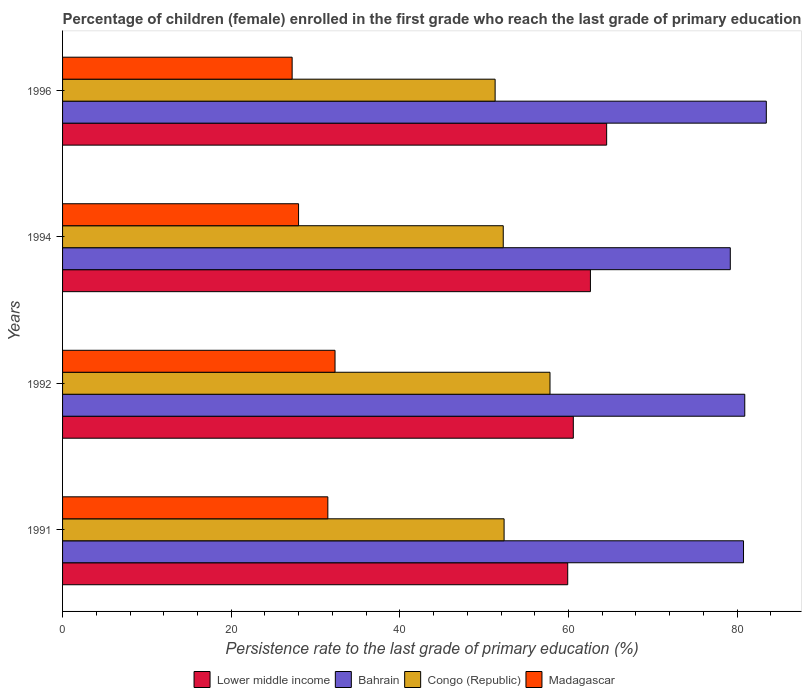Are the number of bars on each tick of the Y-axis equal?
Your answer should be very brief. Yes. How many bars are there on the 3rd tick from the top?
Ensure brevity in your answer.  4. What is the persistence rate of children in Lower middle income in 1994?
Give a very brief answer. 62.61. Across all years, what is the maximum persistence rate of children in Lower middle income?
Ensure brevity in your answer.  64.53. Across all years, what is the minimum persistence rate of children in Bahrain?
Ensure brevity in your answer.  79.19. In which year was the persistence rate of children in Madagascar maximum?
Provide a succinct answer. 1992. What is the total persistence rate of children in Madagascar in the graph?
Offer a very short reply. 119. What is the difference between the persistence rate of children in Congo (Republic) in 1991 and that in 1994?
Provide a succinct answer. 0.1. What is the difference between the persistence rate of children in Lower middle income in 1992 and the persistence rate of children in Congo (Republic) in 1996?
Provide a succinct answer. 9.27. What is the average persistence rate of children in Congo (Republic) per year?
Offer a very short reply. 53.44. In the year 1992, what is the difference between the persistence rate of children in Lower middle income and persistence rate of children in Bahrain?
Your answer should be very brief. -20.33. What is the ratio of the persistence rate of children in Lower middle income in 1991 to that in 1996?
Offer a very short reply. 0.93. Is the difference between the persistence rate of children in Lower middle income in 1992 and 1996 greater than the difference between the persistence rate of children in Bahrain in 1992 and 1996?
Provide a succinct answer. No. What is the difference between the highest and the second highest persistence rate of children in Lower middle income?
Ensure brevity in your answer.  1.93. What is the difference between the highest and the lowest persistence rate of children in Madagascar?
Keep it short and to the point. 5.09. In how many years, is the persistence rate of children in Bahrain greater than the average persistence rate of children in Bahrain taken over all years?
Provide a succinct answer. 1. Is the sum of the persistence rate of children in Bahrain in 1991 and 1994 greater than the maximum persistence rate of children in Congo (Republic) across all years?
Make the answer very short. Yes. Is it the case that in every year, the sum of the persistence rate of children in Lower middle income and persistence rate of children in Madagascar is greater than the sum of persistence rate of children in Bahrain and persistence rate of children in Congo (Republic)?
Your response must be concise. No. What does the 4th bar from the top in 1991 represents?
Provide a short and direct response. Lower middle income. What does the 3rd bar from the bottom in 1994 represents?
Make the answer very short. Congo (Republic). Is it the case that in every year, the sum of the persistence rate of children in Madagascar and persistence rate of children in Lower middle income is greater than the persistence rate of children in Congo (Republic)?
Offer a very short reply. Yes. How many years are there in the graph?
Keep it short and to the point. 4. Are the values on the major ticks of X-axis written in scientific E-notation?
Your response must be concise. No. How many legend labels are there?
Your answer should be compact. 4. What is the title of the graph?
Your answer should be very brief. Percentage of children (female) enrolled in the first grade who reach the last grade of primary education. Does "Antigua and Barbuda" appear as one of the legend labels in the graph?
Make the answer very short. No. What is the label or title of the X-axis?
Your answer should be compact. Persistence rate to the last grade of primary education (%). What is the Persistence rate to the last grade of primary education (%) of Lower middle income in 1991?
Offer a terse response. 59.91. What is the Persistence rate to the last grade of primary education (%) of Bahrain in 1991?
Give a very brief answer. 80.76. What is the Persistence rate to the last grade of primary education (%) in Congo (Republic) in 1991?
Offer a terse response. 52.37. What is the Persistence rate to the last grade of primary education (%) in Madagascar in 1991?
Provide a succinct answer. 31.46. What is the Persistence rate to the last grade of primary education (%) of Lower middle income in 1992?
Make the answer very short. 60.58. What is the Persistence rate to the last grade of primary education (%) in Bahrain in 1992?
Offer a terse response. 80.91. What is the Persistence rate to the last grade of primary education (%) in Congo (Republic) in 1992?
Your answer should be very brief. 57.81. What is the Persistence rate to the last grade of primary education (%) in Madagascar in 1992?
Provide a short and direct response. 32.32. What is the Persistence rate to the last grade of primary education (%) of Lower middle income in 1994?
Offer a very short reply. 62.61. What is the Persistence rate to the last grade of primary education (%) in Bahrain in 1994?
Ensure brevity in your answer.  79.19. What is the Persistence rate to the last grade of primary education (%) in Congo (Republic) in 1994?
Provide a short and direct response. 52.27. What is the Persistence rate to the last grade of primary education (%) in Madagascar in 1994?
Your answer should be very brief. 27.99. What is the Persistence rate to the last grade of primary education (%) in Lower middle income in 1996?
Your response must be concise. 64.53. What is the Persistence rate to the last grade of primary education (%) of Bahrain in 1996?
Offer a very short reply. 83.47. What is the Persistence rate to the last grade of primary education (%) of Congo (Republic) in 1996?
Provide a short and direct response. 51.3. What is the Persistence rate to the last grade of primary education (%) in Madagascar in 1996?
Offer a very short reply. 27.23. Across all years, what is the maximum Persistence rate to the last grade of primary education (%) of Lower middle income?
Your response must be concise. 64.53. Across all years, what is the maximum Persistence rate to the last grade of primary education (%) of Bahrain?
Offer a very short reply. 83.47. Across all years, what is the maximum Persistence rate to the last grade of primary education (%) of Congo (Republic)?
Your answer should be compact. 57.81. Across all years, what is the maximum Persistence rate to the last grade of primary education (%) of Madagascar?
Your response must be concise. 32.32. Across all years, what is the minimum Persistence rate to the last grade of primary education (%) in Lower middle income?
Provide a succinct answer. 59.91. Across all years, what is the minimum Persistence rate to the last grade of primary education (%) of Bahrain?
Offer a terse response. 79.19. Across all years, what is the minimum Persistence rate to the last grade of primary education (%) of Congo (Republic)?
Ensure brevity in your answer.  51.3. Across all years, what is the minimum Persistence rate to the last grade of primary education (%) of Madagascar?
Give a very brief answer. 27.23. What is the total Persistence rate to the last grade of primary education (%) in Lower middle income in the graph?
Provide a succinct answer. 247.63. What is the total Persistence rate to the last grade of primary education (%) in Bahrain in the graph?
Provide a succinct answer. 324.34. What is the total Persistence rate to the last grade of primary education (%) in Congo (Republic) in the graph?
Keep it short and to the point. 213.75. What is the total Persistence rate to the last grade of primary education (%) of Madagascar in the graph?
Provide a short and direct response. 119. What is the difference between the Persistence rate to the last grade of primary education (%) in Lower middle income in 1991 and that in 1992?
Offer a very short reply. -0.66. What is the difference between the Persistence rate to the last grade of primary education (%) of Bahrain in 1991 and that in 1992?
Your response must be concise. -0.15. What is the difference between the Persistence rate to the last grade of primary education (%) in Congo (Republic) in 1991 and that in 1992?
Make the answer very short. -5.44. What is the difference between the Persistence rate to the last grade of primary education (%) of Madagascar in 1991 and that in 1992?
Offer a terse response. -0.85. What is the difference between the Persistence rate to the last grade of primary education (%) of Lower middle income in 1991 and that in 1994?
Keep it short and to the point. -2.69. What is the difference between the Persistence rate to the last grade of primary education (%) of Bahrain in 1991 and that in 1994?
Give a very brief answer. 1.57. What is the difference between the Persistence rate to the last grade of primary education (%) of Congo (Republic) in 1991 and that in 1994?
Keep it short and to the point. 0.1. What is the difference between the Persistence rate to the last grade of primary education (%) of Madagascar in 1991 and that in 1994?
Make the answer very short. 3.47. What is the difference between the Persistence rate to the last grade of primary education (%) in Lower middle income in 1991 and that in 1996?
Your answer should be very brief. -4.62. What is the difference between the Persistence rate to the last grade of primary education (%) in Bahrain in 1991 and that in 1996?
Provide a succinct answer. -2.7. What is the difference between the Persistence rate to the last grade of primary education (%) of Congo (Republic) in 1991 and that in 1996?
Your response must be concise. 1.06. What is the difference between the Persistence rate to the last grade of primary education (%) of Madagascar in 1991 and that in 1996?
Offer a very short reply. 4.23. What is the difference between the Persistence rate to the last grade of primary education (%) of Lower middle income in 1992 and that in 1994?
Make the answer very short. -2.03. What is the difference between the Persistence rate to the last grade of primary education (%) in Bahrain in 1992 and that in 1994?
Make the answer very short. 1.72. What is the difference between the Persistence rate to the last grade of primary education (%) of Congo (Republic) in 1992 and that in 1994?
Offer a terse response. 5.54. What is the difference between the Persistence rate to the last grade of primary education (%) of Madagascar in 1992 and that in 1994?
Keep it short and to the point. 4.33. What is the difference between the Persistence rate to the last grade of primary education (%) of Lower middle income in 1992 and that in 1996?
Offer a terse response. -3.96. What is the difference between the Persistence rate to the last grade of primary education (%) in Bahrain in 1992 and that in 1996?
Give a very brief answer. -2.55. What is the difference between the Persistence rate to the last grade of primary education (%) of Congo (Republic) in 1992 and that in 1996?
Offer a terse response. 6.51. What is the difference between the Persistence rate to the last grade of primary education (%) in Madagascar in 1992 and that in 1996?
Provide a short and direct response. 5.09. What is the difference between the Persistence rate to the last grade of primary education (%) of Lower middle income in 1994 and that in 1996?
Offer a very short reply. -1.93. What is the difference between the Persistence rate to the last grade of primary education (%) in Bahrain in 1994 and that in 1996?
Provide a succinct answer. -4.27. What is the difference between the Persistence rate to the last grade of primary education (%) in Madagascar in 1994 and that in 1996?
Keep it short and to the point. 0.76. What is the difference between the Persistence rate to the last grade of primary education (%) in Lower middle income in 1991 and the Persistence rate to the last grade of primary education (%) in Bahrain in 1992?
Keep it short and to the point. -21. What is the difference between the Persistence rate to the last grade of primary education (%) of Lower middle income in 1991 and the Persistence rate to the last grade of primary education (%) of Congo (Republic) in 1992?
Provide a succinct answer. 2.1. What is the difference between the Persistence rate to the last grade of primary education (%) of Lower middle income in 1991 and the Persistence rate to the last grade of primary education (%) of Madagascar in 1992?
Offer a terse response. 27.6. What is the difference between the Persistence rate to the last grade of primary education (%) of Bahrain in 1991 and the Persistence rate to the last grade of primary education (%) of Congo (Republic) in 1992?
Keep it short and to the point. 22.95. What is the difference between the Persistence rate to the last grade of primary education (%) in Bahrain in 1991 and the Persistence rate to the last grade of primary education (%) in Madagascar in 1992?
Make the answer very short. 48.45. What is the difference between the Persistence rate to the last grade of primary education (%) of Congo (Republic) in 1991 and the Persistence rate to the last grade of primary education (%) of Madagascar in 1992?
Ensure brevity in your answer.  20.05. What is the difference between the Persistence rate to the last grade of primary education (%) in Lower middle income in 1991 and the Persistence rate to the last grade of primary education (%) in Bahrain in 1994?
Offer a terse response. -19.28. What is the difference between the Persistence rate to the last grade of primary education (%) of Lower middle income in 1991 and the Persistence rate to the last grade of primary education (%) of Congo (Republic) in 1994?
Give a very brief answer. 7.64. What is the difference between the Persistence rate to the last grade of primary education (%) in Lower middle income in 1991 and the Persistence rate to the last grade of primary education (%) in Madagascar in 1994?
Provide a succinct answer. 31.92. What is the difference between the Persistence rate to the last grade of primary education (%) of Bahrain in 1991 and the Persistence rate to the last grade of primary education (%) of Congo (Republic) in 1994?
Your answer should be compact. 28.5. What is the difference between the Persistence rate to the last grade of primary education (%) in Bahrain in 1991 and the Persistence rate to the last grade of primary education (%) in Madagascar in 1994?
Provide a short and direct response. 52.77. What is the difference between the Persistence rate to the last grade of primary education (%) in Congo (Republic) in 1991 and the Persistence rate to the last grade of primary education (%) in Madagascar in 1994?
Provide a succinct answer. 24.38. What is the difference between the Persistence rate to the last grade of primary education (%) of Lower middle income in 1991 and the Persistence rate to the last grade of primary education (%) of Bahrain in 1996?
Your answer should be compact. -23.55. What is the difference between the Persistence rate to the last grade of primary education (%) of Lower middle income in 1991 and the Persistence rate to the last grade of primary education (%) of Congo (Republic) in 1996?
Your answer should be compact. 8.61. What is the difference between the Persistence rate to the last grade of primary education (%) of Lower middle income in 1991 and the Persistence rate to the last grade of primary education (%) of Madagascar in 1996?
Provide a short and direct response. 32.68. What is the difference between the Persistence rate to the last grade of primary education (%) in Bahrain in 1991 and the Persistence rate to the last grade of primary education (%) in Congo (Republic) in 1996?
Offer a terse response. 29.46. What is the difference between the Persistence rate to the last grade of primary education (%) in Bahrain in 1991 and the Persistence rate to the last grade of primary education (%) in Madagascar in 1996?
Make the answer very short. 53.54. What is the difference between the Persistence rate to the last grade of primary education (%) in Congo (Republic) in 1991 and the Persistence rate to the last grade of primary education (%) in Madagascar in 1996?
Make the answer very short. 25.14. What is the difference between the Persistence rate to the last grade of primary education (%) in Lower middle income in 1992 and the Persistence rate to the last grade of primary education (%) in Bahrain in 1994?
Offer a very short reply. -18.62. What is the difference between the Persistence rate to the last grade of primary education (%) of Lower middle income in 1992 and the Persistence rate to the last grade of primary education (%) of Congo (Republic) in 1994?
Provide a short and direct response. 8.31. What is the difference between the Persistence rate to the last grade of primary education (%) in Lower middle income in 1992 and the Persistence rate to the last grade of primary education (%) in Madagascar in 1994?
Your answer should be compact. 32.59. What is the difference between the Persistence rate to the last grade of primary education (%) in Bahrain in 1992 and the Persistence rate to the last grade of primary education (%) in Congo (Republic) in 1994?
Provide a short and direct response. 28.64. What is the difference between the Persistence rate to the last grade of primary education (%) in Bahrain in 1992 and the Persistence rate to the last grade of primary education (%) in Madagascar in 1994?
Ensure brevity in your answer.  52.92. What is the difference between the Persistence rate to the last grade of primary education (%) in Congo (Republic) in 1992 and the Persistence rate to the last grade of primary education (%) in Madagascar in 1994?
Keep it short and to the point. 29.82. What is the difference between the Persistence rate to the last grade of primary education (%) of Lower middle income in 1992 and the Persistence rate to the last grade of primary education (%) of Bahrain in 1996?
Your answer should be very brief. -22.89. What is the difference between the Persistence rate to the last grade of primary education (%) in Lower middle income in 1992 and the Persistence rate to the last grade of primary education (%) in Congo (Republic) in 1996?
Offer a terse response. 9.27. What is the difference between the Persistence rate to the last grade of primary education (%) in Lower middle income in 1992 and the Persistence rate to the last grade of primary education (%) in Madagascar in 1996?
Ensure brevity in your answer.  33.35. What is the difference between the Persistence rate to the last grade of primary education (%) of Bahrain in 1992 and the Persistence rate to the last grade of primary education (%) of Congo (Republic) in 1996?
Make the answer very short. 29.61. What is the difference between the Persistence rate to the last grade of primary education (%) of Bahrain in 1992 and the Persistence rate to the last grade of primary education (%) of Madagascar in 1996?
Your response must be concise. 53.68. What is the difference between the Persistence rate to the last grade of primary education (%) of Congo (Republic) in 1992 and the Persistence rate to the last grade of primary education (%) of Madagascar in 1996?
Keep it short and to the point. 30.58. What is the difference between the Persistence rate to the last grade of primary education (%) in Lower middle income in 1994 and the Persistence rate to the last grade of primary education (%) in Bahrain in 1996?
Your answer should be very brief. -20.86. What is the difference between the Persistence rate to the last grade of primary education (%) of Lower middle income in 1994 and the Persistence rate to the last grade of primary education (%) of Congo (Republic) in 1996?
Give a very brief answer. 11.3. What is the difference between the Persistence rate to the last grade of primary education (%) in Lower middle income in 1994 and the Persistence rate to the last grade of primary education (%) in Madagascar in 1996?
Keep it short and to the point. 35.38. What is the difference between the Persistence rate to the last grade of primary education (%) in Bahrain in 1994 and the Persistence rate to the last grade of primary education (%) in Congo (Republic) in 1996?
Make the answer very short. 27.89. What is the difference between the Persistence rate to the last grade of primary education (%) in Bahrain in 1994 and the Persistence rate to the last grade of primary education (%) in Madagascar in 1996?
Your answer should be very brief. 51.97. What is the difference between the Persistence rate to the last grade of primary education (%) in Congo (Republic) in 1994 and the Persistence rate to the last grade of primary education (%) in Madagascar in 1996?
Offer a terse response. 25.04. What is the average Persistence rate to the last grade of primary education (%) in Lower middle income per year?
Provide a short and direct response. 61.91. What is the average Persistence rate to the last grade of primary education (%) in Bahrain per year?
Your answer should be very brief. 81.08. What is the average Persistence rate to the last grade of primary education (%) in Congo (Republic) per year?
Your answer should be compact. 53.44. What is the average Persistence rate to the last grade of primary education (%) in Madagascar per year?
Offer a very short reply. 29.75. In the year 1991, what is the difference between the Persistence rate to the last grade of primary education (%) of Lower middle income and Persistence rate to the last grade of primary education (%) of Bahrain?
Offer a terse response. -20.85. In the year 1991, what is the difference between the Persistence rate to the last grade of primary education (%) in Lower middle income and Persistence rate to the last grade of primary education (%) in Congo (Republic)?
Give a very brief answer. 7.55. In the year 1991, what is the difference between the Persistence rate to the last grade of primary education (%) of Lower middle income and Persistence rate to the last grade of primary education (%) of Madagascar?
Your response must be concise. 28.45. In the year 1991, what is the difference between the Persistence rate to the last grade of primary education (%) of Bahrain and Persistence rate to the last grade of primary education (%) of Congo (Republic)?
Keep it short and to the point. 28.4. In the year 1991, what is the difference between the Persistence rate to the last grade of primary education (%) in Bahrain and Persistence rate to the last grade of primary education (%) in Madagascar?
Offer a terse response. 49.3. In the year 1991, what is the difference between the Persistence rate to the last grade of primary education (%) of Congo (Republic) and Persistence rate to the last grade of primary education (%) of Madagascar?
Keep it short and to the point. 20.9. In the year 1992, what is the difference between the Persistence rate to the last grade of primary education (%) in Lower middle income and Persistence rate to the last grade of primary education (%) in Bahrain?
Your answer should be very brief. -20.33. In the year 1992, what is the difference between the Persistence rate to the last grade of primary education (%) in Lower middle income and Persistence rate to the last grade of primary education (%) in Congo (Republic)?
Your response must be concise. 2.77. In the year 1992, what is the difference between the Persistence rate to the last grade of primary education (%) of Lower middle income and Persistence rate to the last grade of primary education (%) of Madagascar?
Your answer should be very brief. 28.26. In the year 1992, what is the difference between the Persistence rate to the last grade of primary education (%) of Bahrain and Persistence rate to the last grade of primary education (%) of Congo (Republic)?
Make the answer very short. 23.1. In the year 1992, what is the difference between the Persistence rate to the last grade of primary education (%) in Bahrain and Persistence rate to the last grade of primary education (%) in Madagascar?
Give a very brief answer. 48.6. In the year 1992, what is the difference between the Persistence rate to the last grade of primary education (%) of Congo (Republic) and Persistence rate to the last grade of primary education (%) of Madagascar?
Give a very brief answer. 25.5. In the year 1994, what is the difference between the Persistence rate to the last grade of primary education (%) in Lower middle income and Persistence rate to the last grade of primary education (%) in Bahrain?
Your answer should be very brief. -16.59. In the year 1994, what is the difference between the Persistence rate to the last grade of primary education (%) of Lower middle income and Persistence rate to the last grade of primary education (%) of Congo (Republic)?
Make the answer very short. 10.34. In the year 1994, what is the difference between the Persistence rate to the last grade of primary education (%) of Lower middle income and Persistence rate to the last grade of primary education (%) of Madagascar?
Make the answer very short. 34.62. In the year 1994, what is the difference between the Persistence rate to the last grade of primary education (%) in Bahrain and Persistence rate to the last grade of primary education (%) in Congo (Republic)?
Provide a short and direct response. 26.93. In the year 1994, what is the difference between the Persistence rate to the last grade of primary education (%) in Bahrain and Persistence rate to the last grade of primary education (%) in Madagascar?
Offer a terse response. 51.2. In the year 1994, what is the difference between the Persistence rate to the last grade of primary education (%) in Congo (Republic) and Persistence rate to the last grade of primary education (%) in Madagascar?
Your answer should be very brief. 24.28. In the year 1996, what is the difference between the Persistence rate to the last grade of primary education (%) in Lower middle income and Persistence rate to the last grade of primary education (%) in Bahrain?
Make the answer very short. -18.93. In the year 1996, what is the difference between the Persistence rate to the last grade of primary education (%) of Lower middle income and Persistence rate to the last grade of primary education (%) of Congo (Republic)?
Ensure brevity in your answer.  13.23. In the year 1996, what is the difference between the Persistence rate to the last grade of primary education (%) in Lower middle income and Persistence rate to the last grade of primary education (%) in Madagascar?
Your answer should be compact. 37.3. In the year 1996, what is the difference between the Persistence rate to the last grade of primary education (%) of Bahrain and Persistence rate to the last grade of primary education (%) of Congo (Republic)?
Ensure brevity in your answer.  32.16. In the year 1996, what is the difference between the Persistence rate to the last grade of primary education (%) in Bahrain and Persistence rate to the last grade of primary education (%) in Madagascar?
Provide a succinct answer. 56.24. In the year 1996, what is the difference between the Persistence rate to the last grade of primary education (%) of Congo (Republic) and Persistence rate to the last grade of primary education (%) of Madagascar?
Offer a terse response. 24.07. What is the ratio of the Persistence rate to the last grade of primary education (%) of Bahrain in 1991 to that in 1992?
Offer a terse response. 1. What is the ratio of the Persistence rate to the last grade of primary education (%) in Congo (Republic) in 1991 to that in 1992?
Offer a terse response. 0.91. What is the ratio of the Persistence rate to the last grade of primary education (%) of Madagascar in 1991 to that in 1992?
Keep it short and to the point. 0.97. What is the ratio of the Persistence rate to the last grade of primary education (%) in Bahrain in 1991 to that in 1994?
Keep it short and to the point. 1.02. What is the ratio of the Persistence rate to the last grade of primary education (%) of Congo (Republic) in 1991 to that in 1994?
Ensure brevity in your answer.  1. What is the ratio of the Persistence rate to the last grade of primary education (%) of Madagascar in 1991 to that in 1994?
Your answer should be very brief. 1.12. What is the ratio of the Persistence rate to the last grade of primary education (%) in Lower middle income in 1991 to that in 1996?
Your response must be concise. 0.93. What is the ratio of the Persistence rate to the last grade of primary education (%) in Bahrain in 1991 to that in 1996?
Make the answer very short. 0.97. What is the ratio of the Persistence rate to the last grade of primary education (%) of Congo (Republic) in 1991 to that in 1996?
Offer a terse response. 1.02. What is the ratio of the Persistence rate to the last grade of primary education (%) in Madagascar in 1991 to that in 1996?
Give a very brief answer. 1.16. What is the ratio of the Persistence rate to the last grade of primary education (%) in Lower middle income in 1992 to that in 1994?
Your answer should be very brief. 0.97. What is the ratio of the Persistence rate to the last grade of primary education (%) in Bahrain in 1992 to that in 1994?
Provide a short and direct response. 1.02. What is the ratio of the Persistence rate to the last grade of primary education (%) in Congo (Republic) in 1992 to that in 1994?
Offer a terse response. 1.11. What is the ratio of the Persistence rate to the last grade of primary education (%) of Madagascar in 1992 to that in 1994?
Your answer should be compact. 1.15. What is the ratio of the Persistence rate to the last grade of primary education (%) in Lower middle income in 1992 to that in 1996?
Your answer should be very brief. 0.94. What is the ratio of the Persistence rate to the last grade of primary education (%) in Bahrain in 1992 to that in 1996?
Keep it short and to the point. 0.97. What is the ratio of the Persistence rate to the last grade of primary education (%) in Congo (Republic) in 1992 to that in 1996?
Your answer should be compact. 1.13. What is the ratio of the Persistence rate to the last grade of primary education (%) in Madagascar in 1992 to that in 1996?
Your response must be concise. 1.19. What is the ratio of the Persistence rate to the last grade of primary education (%) of Lower middle income in 1994 to that in 1996?
Your answer should be compact. 0.97. What is the ratio of the Persistence rate to the last grade of primary education (%) in Bahrain in 1994 to that in 1996?
Your response must be concise. 0.95. What is the ratio of the Persistence rate to the last grade of primary education (%) of Congo (Republic) in 1994 to that in 1996?
Ensure brevity in your answer.  1.02. What is the ratio of the Persistence rate to the last grade of primary education (%) in Madagascar in 1994 to that in 1996?
Keep it short and to the point. 1.03. What is the difference between the highest and the second highest Persistence rate to the last grade of primary education (%) in Lower middle income?
Your answer should be very brief. 1.93. What is the difference between the highest and the second highest Persistence rate to the last grade of primary education (%) of Bahrain?
Offer a terse response. 2.55. What is the difference between the highest and the second highest Persistence rate to the last grade of primary education (%) in Congo (Republic)?
Provide a short and direct response. 5.44. What is the difference between the highest and the second highest Persistence rate to the last grade of primary education (%) in Madagascar?
Provide a succinct answer. 0.85. What is the difference between the highest and the lowest Persistence rate to the last grade of primary education (%) in Lower middle income?
Make the answer very short. 4.62. What is the difference between the highest and the lowest Persistence rate to the last grade of primary education (%) of Bahrain?
Your answer should be compact. 4.27. What is the difference between the highest and the lowest Persistence rate to the last grade of primary education (%) in Congo (Republic)?
Offer a terse response. 6.51. What is the difference between the highest and the lowest Persistence rate to the last grade of primary education (%) in Madagascar?
Offer a terse response. 5.09. 